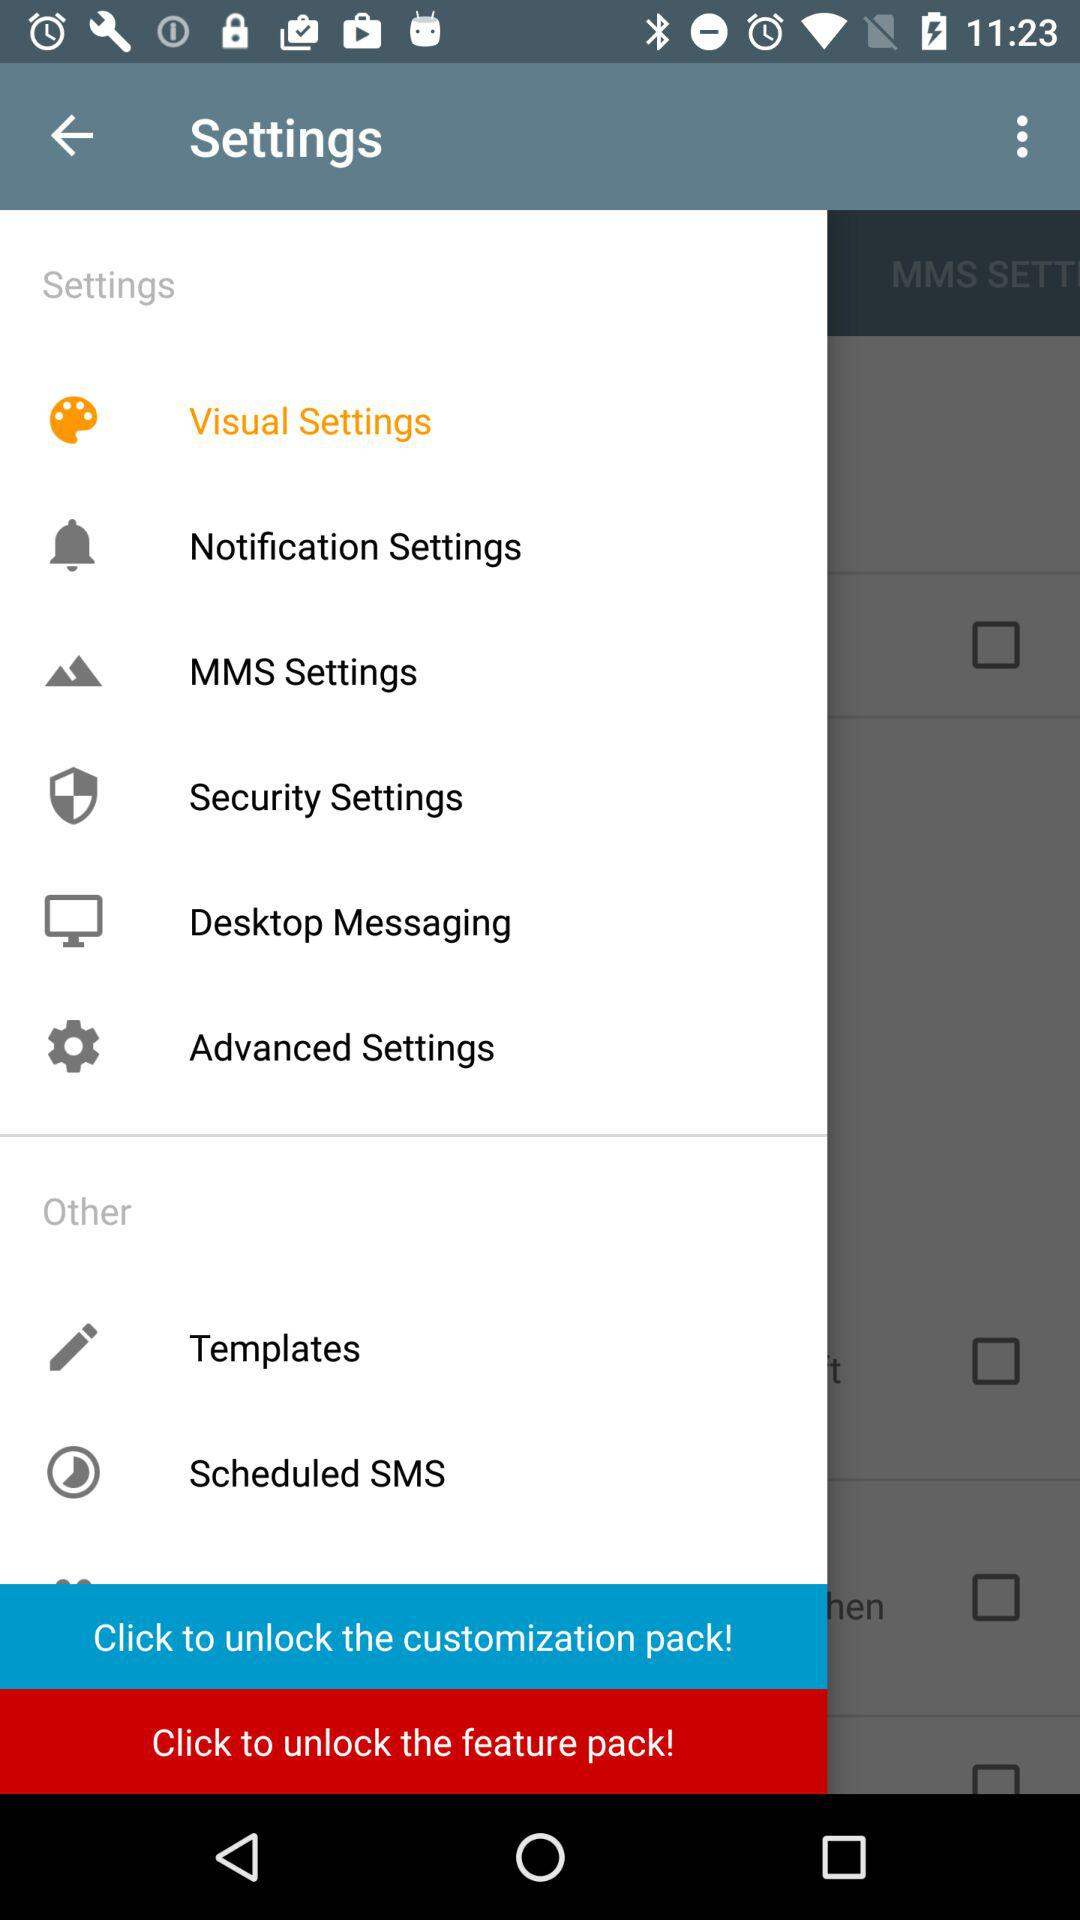How many checkboxes can be found on this screen?
Answer the question using a single word or phrase. 4 